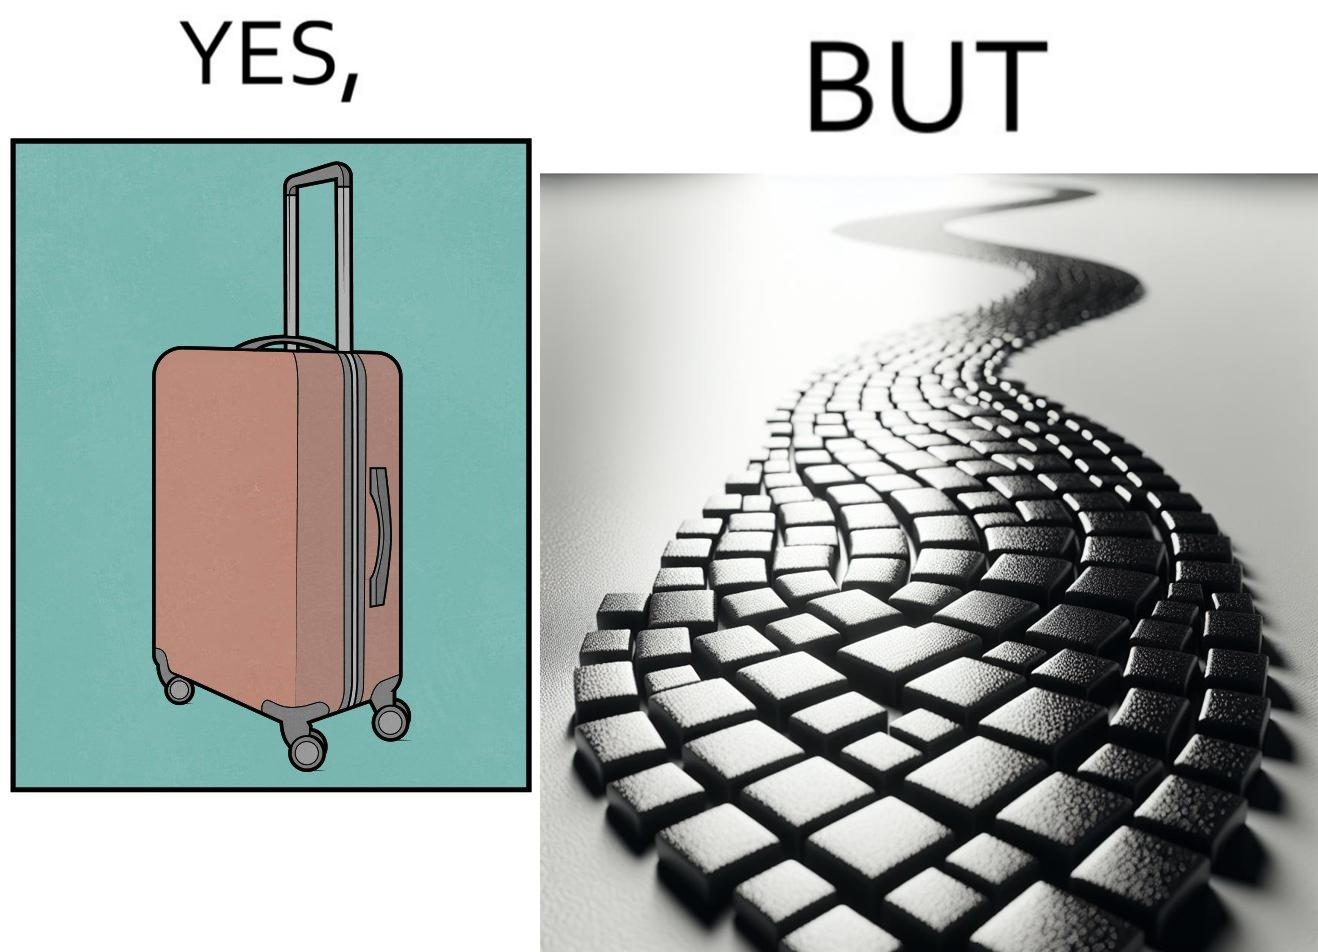Describe what you see in the left and right parts of this image. In the left part of the image: it is a trolley luggage bag In the right part of the image: It is a cobblestone road 